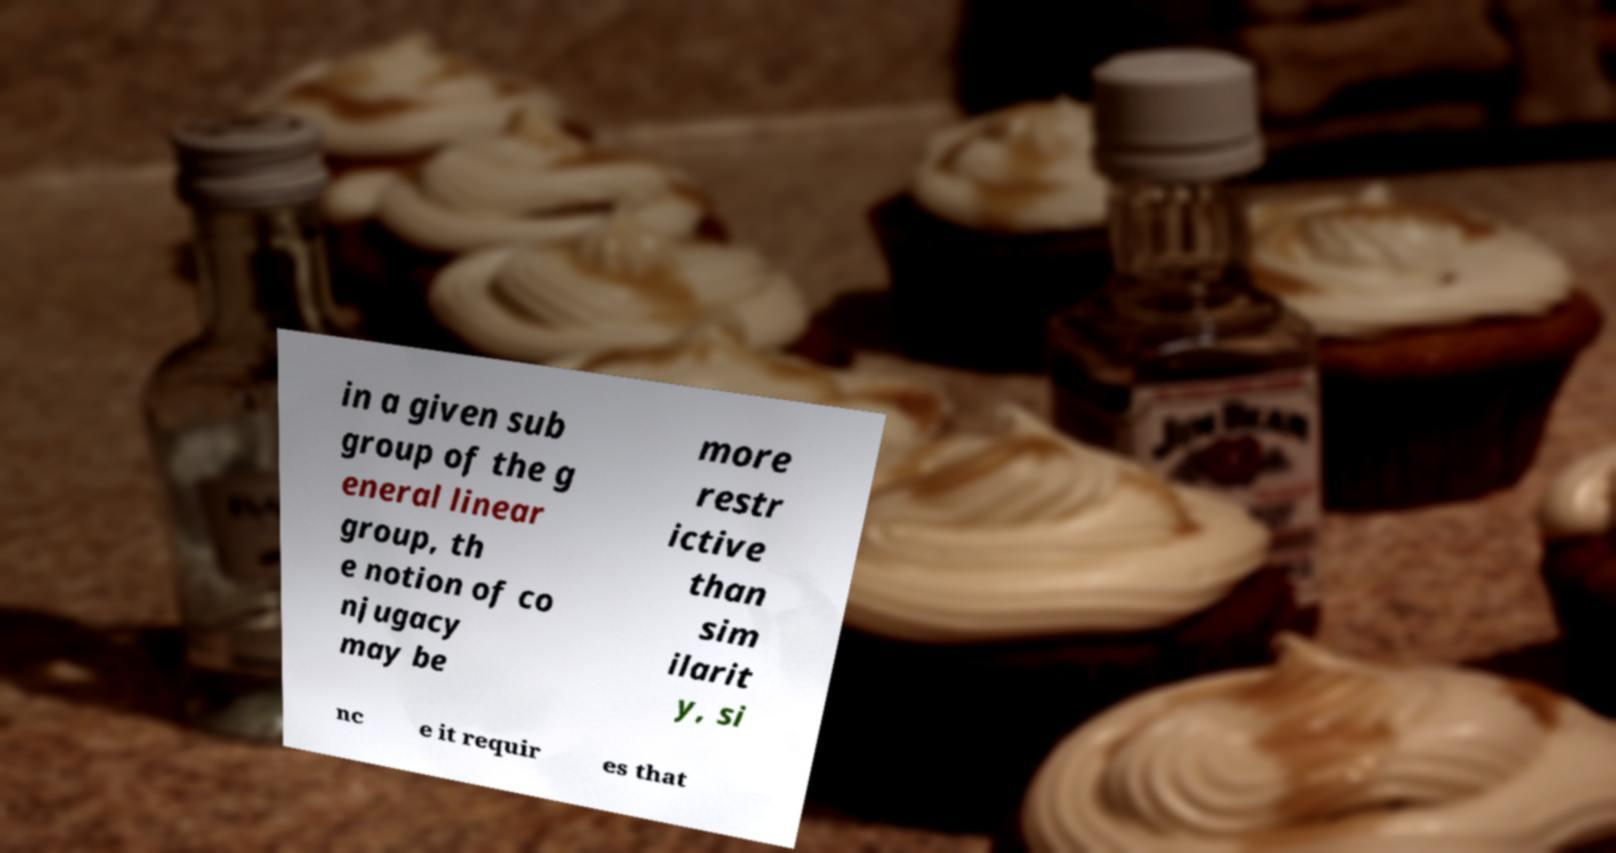Could you assist in decoding the text presented in this image and type it out clearly? in a given sub group of the g eneral linear group, th e notion of co njugacy may be more restr ictive than sim ilarit y, si nc e it requir es that 